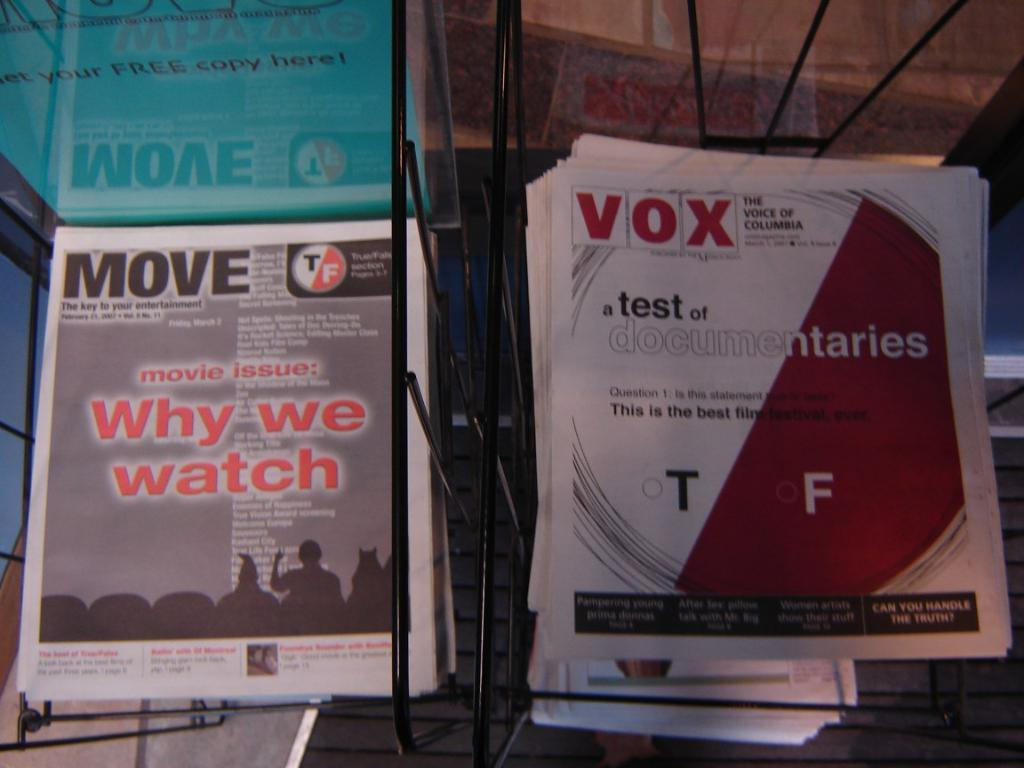<image>
Summarize the visual content of the image. Move and Vox newsletters are placed in side-by-side racks. 